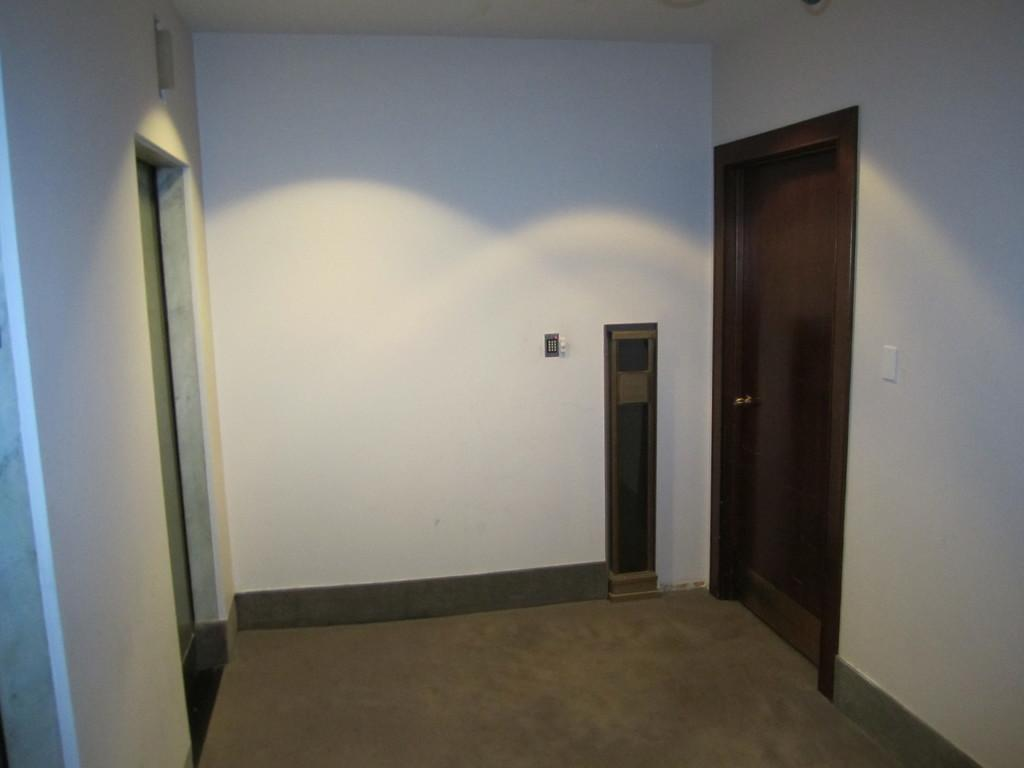What type of structure is present in the image? There is a wall in the image. What feature can be seen on the wall? The wall has switches. Is there any entrance or exit visible in the image? Yes, there is a door in the image. What type of jeans is the beetle wearing in the image? There is no beetle or jeans present in the image; it only features a wall with switches and a door. 